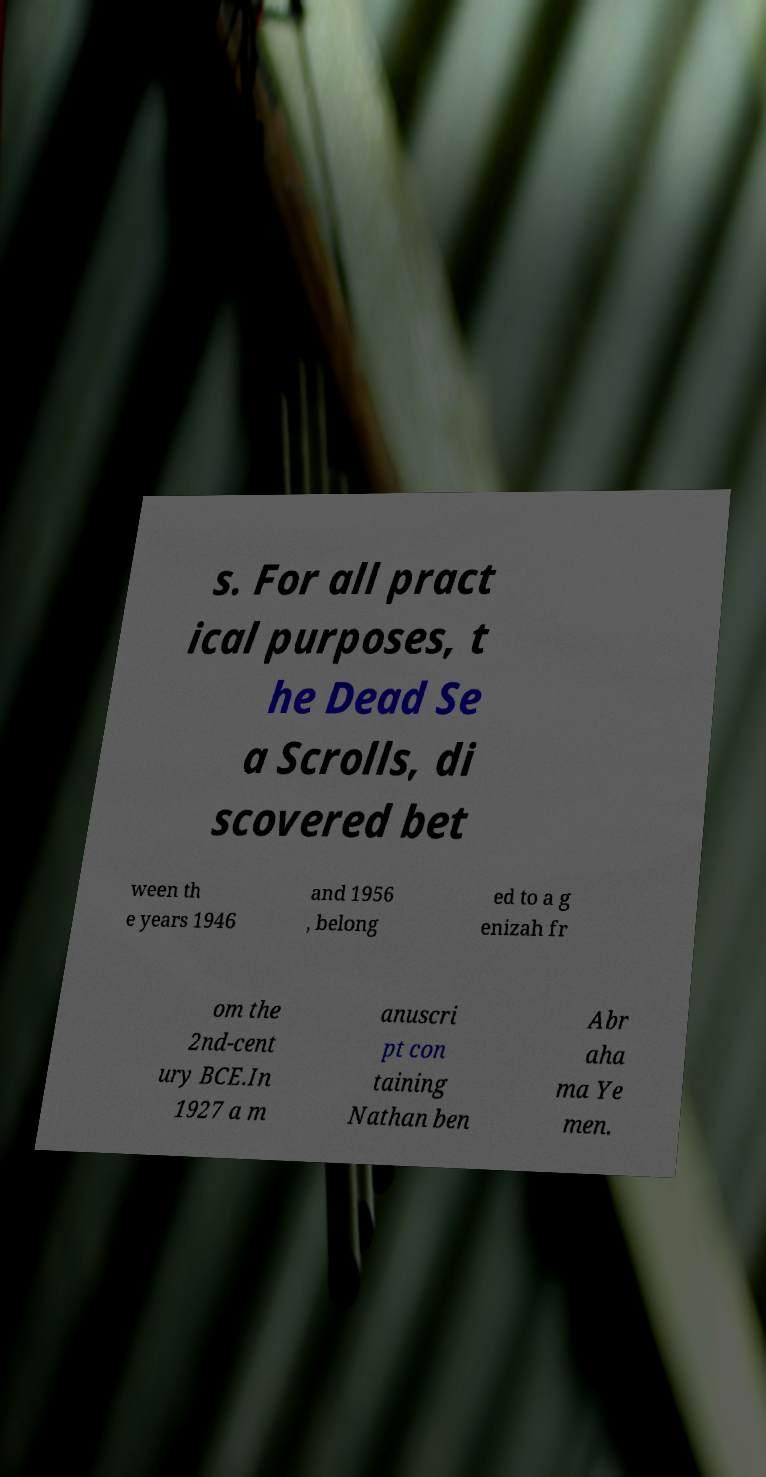Could you assist in decoding the text presented in this image and type it out clearly? s. For all pract ical purposes, t he Dead Se a Scrolls, di scovered bet ween th e years 1946 and 1956 , belong ed to a g enizah fr om the 2nd-cent ury BCE.In 1927 a m anuscri pt con taining Nathan ben Abr aha ma Ye men. 